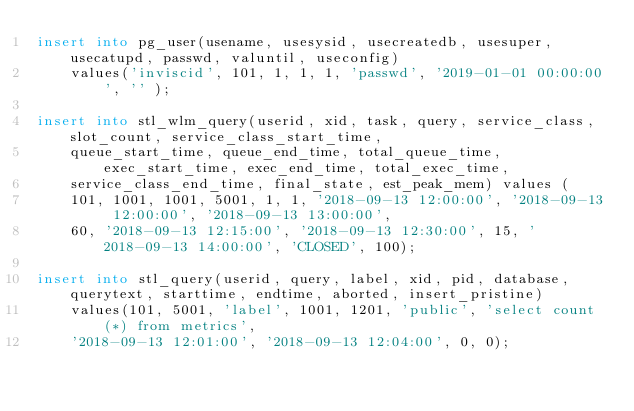Convert code to text. <code><loc_0><loc_0><loc_500><loc_500><_SQL_>insert into pg_user(usename, usesysid, usecreatedb, usesuper, usecatupd, passwd, valuntil, useconfig)
    values('inviscid', 101, 1, 1, 1, 'passwd', '2019-01-01 00:00:00', '' );

insert into stl_wlm_query(userid, xid, task, query, service_class, slot_count, service_class_start_time,
    queue_start_time, queue_end_time, total_queue_time, exec_start_time, exec_end_time, total_exec_time,
    service_class_end_time, final_state, est_peak_mem) values (
    101, 1001, 1001, 5001, 1, 1, '2018-09-13 12:00:00', '2018-09-13 12:00:00', '2018-09-13 13:00:00',
    60, '2018-09-13 12:15:00', '2018-09-13 12:30:00', 15, '2018-09-13 14:00:00', 'CLOSED', 100);

insert into stl_query(userid, query, label, xid, pid, database, querytext, starttime, endtime, aborted, insert_pristine)
    values(101, 5001, 'label', 1001, 1201, 'public', 'select count(*) from metrics',
    '2018-09-13 12:01:00', '2018-09-13 12:04:00', 0, 0);</code> 